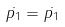Convert formula to latex. <formula><loc_0><loc_0><loc_500><loc_500>\dot { p _ { 1 } } = \dot { p _ { 1 } }</formula> 